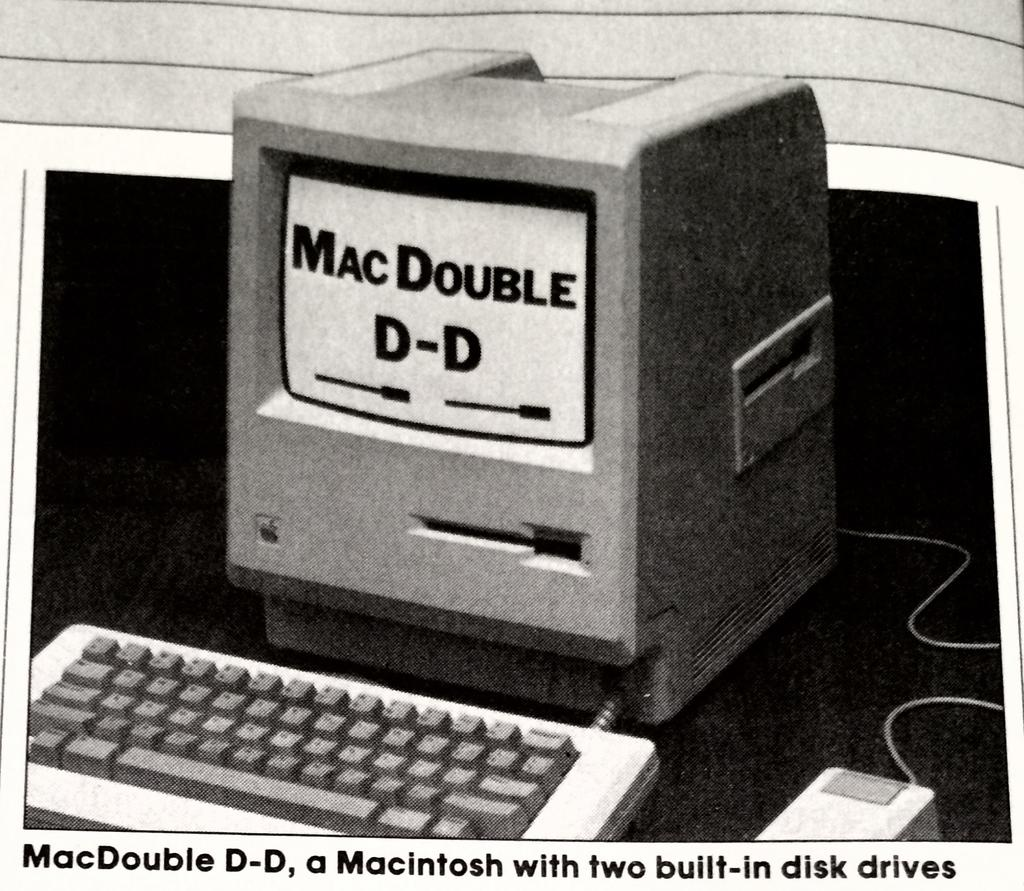<image>
Share a concise interpretation of the image provided. A vintage ad for a MacDouble D-D with two disk drives. 